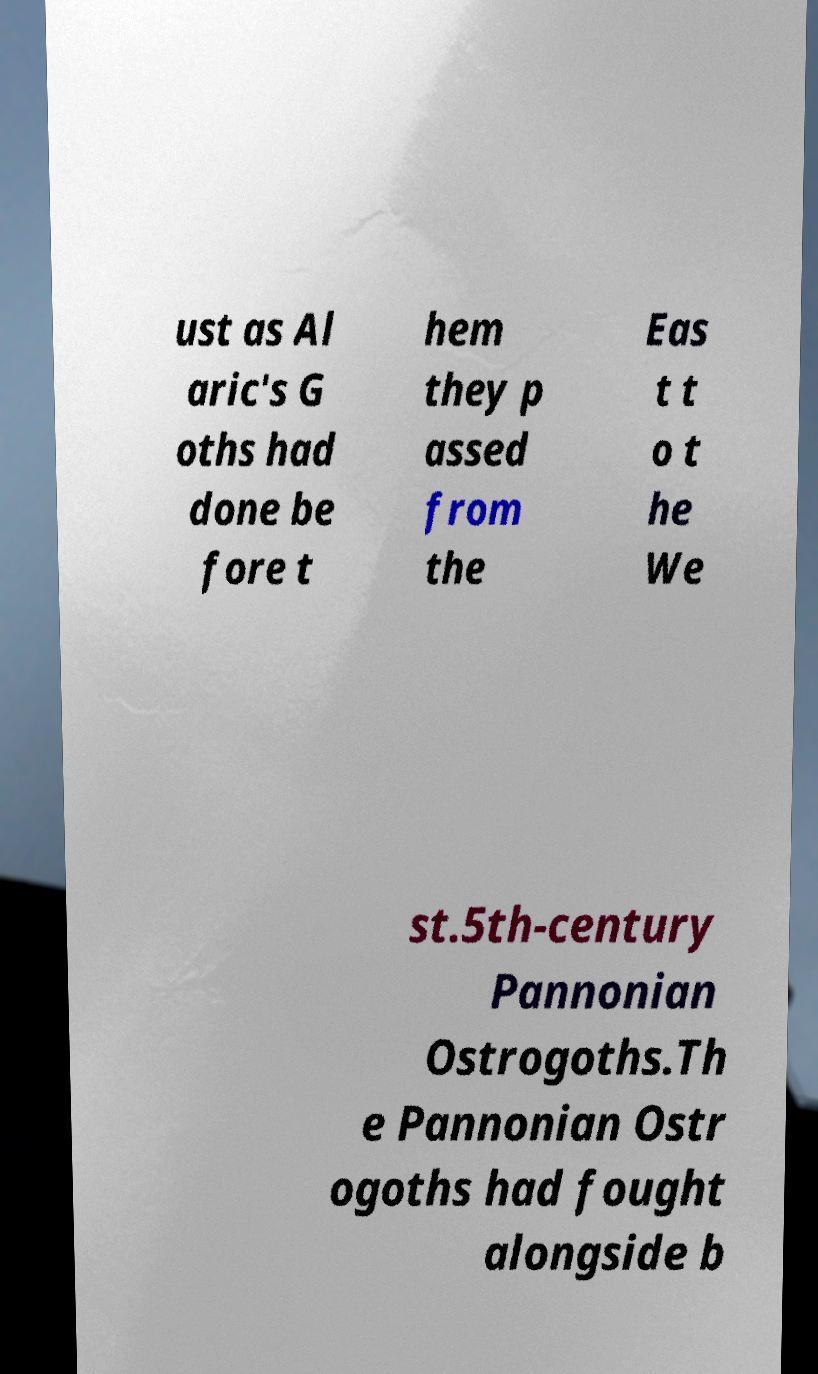Could you assist in decoding the text presented in this image and type it out clearly? ust as Al aric's G oths had done be fore t hem they p assed from the Eas t t o t he We st.5th-century Pannonian Ostrogoths.Th e Pannonian Ostr ogoths had fought alongside b 